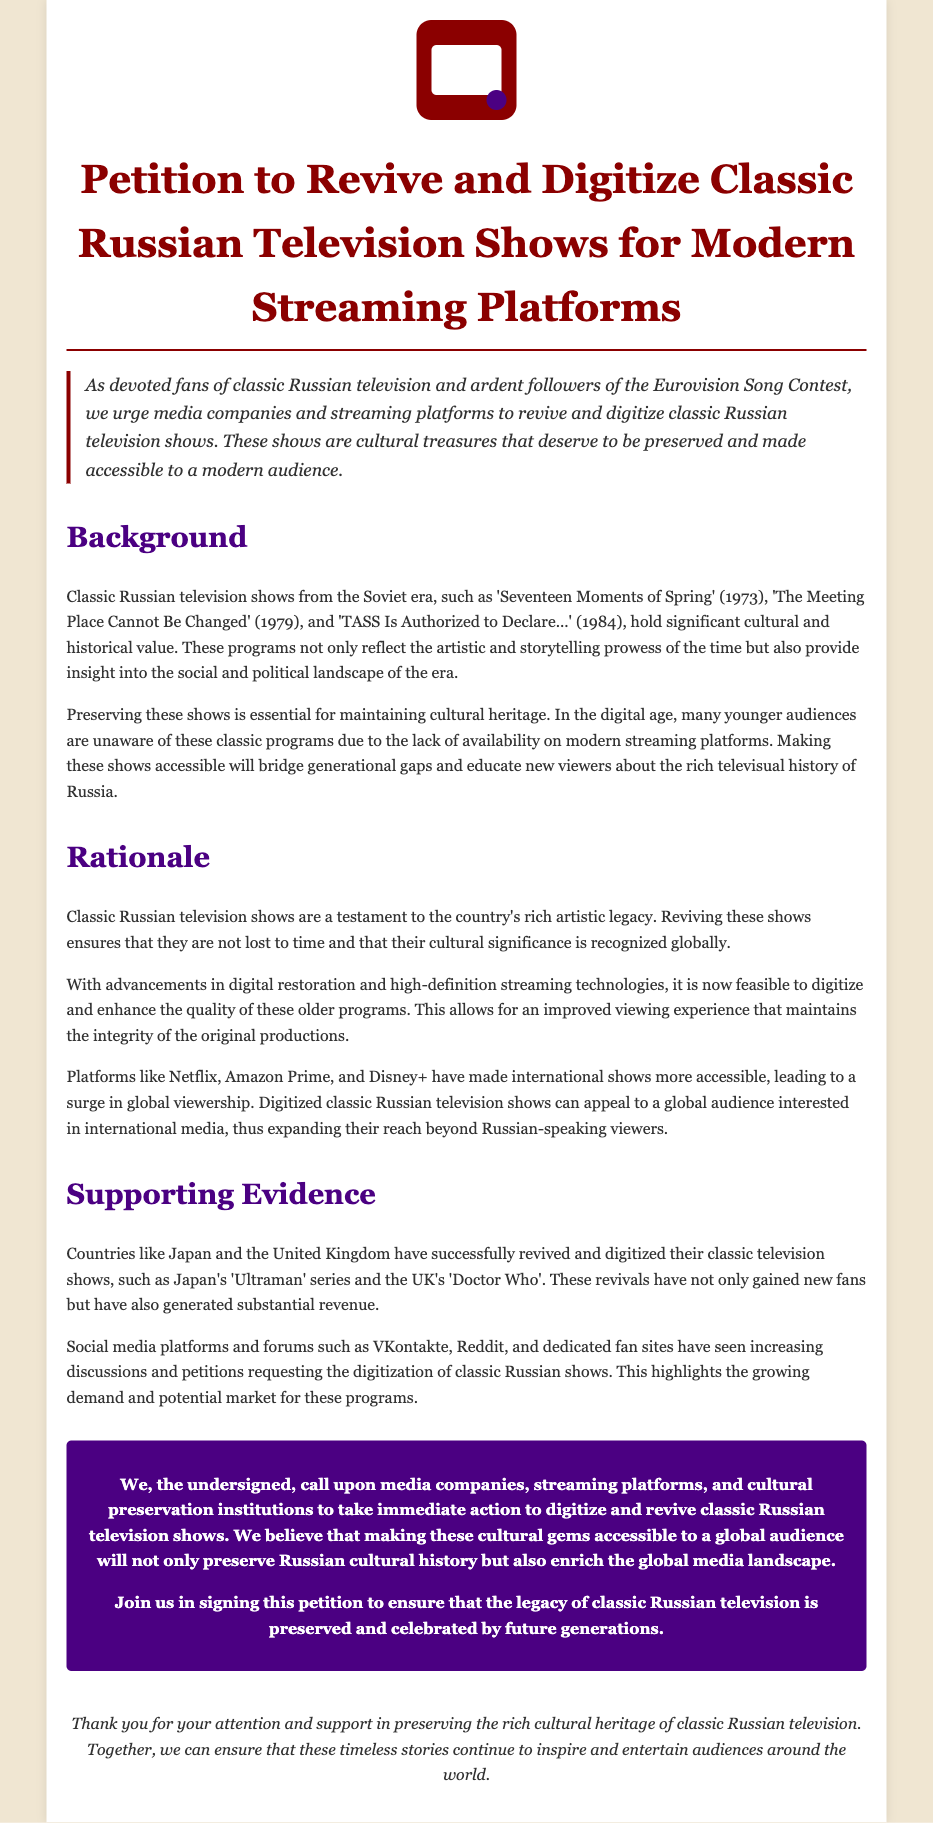What is the title of the petition? The title of the petition is explicitly stated at the beginning of the document.
Answer: Petition to Revive and Digitize Classic Russian Television Shows for Modern Streaming Platforms What year was 'Seventeen Moments of Spring' released? The document mentions the release year of the show as part of its historical context.
Answer: 1973 Which platforms are mentioned for potential digitization? The document lists specific platforms that could host the digitized shows.
Answer: Netflix, Amazon Prime, Disney+ What cultural significance do classic Russian shows hold? The document indicates that these shows provide insight into the social and political landscape of their time.
Answer: Cultural heritage What are the names of two classic Russian television shows mentioned? The document provides examples of shows to highlight their importance.
Answer: Seventeen Moments of Spring, The Meeting Place Cannot Be Changed How do other countries' experiences relate to this petition? The document references successful digitization efforts in other countries to support its rationale.
Answer: Japan, United Kingdom What is the call to action in the petition? The petition includes a direct appeal to specific stakeholders for reviving classic shows.
Answer: Digitize and revive classic Russian television shows What trend is noted concerning discussions about the shows? The document observes a growing interest in these classic shows on social media platforms.
Answer: Increasing discussions and petitions 